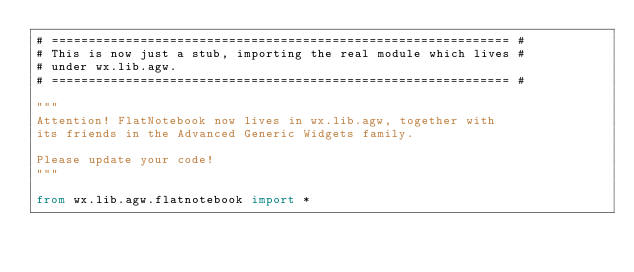<code> <loc_0><loc_0><loc_500><loc_500><_Python_># ============================================================== #
# This is now just a stub, importing the real module which lives #
# under wx.lib.agw.
# ============================================================== #

"""
Attention! FlatNotebook now lives in wx.lib.agw, together with
its friends in the Advanced Generic Widgets family.

Please update your code!
"""

from wx.lib.agw.flatnotebook import *</code> 